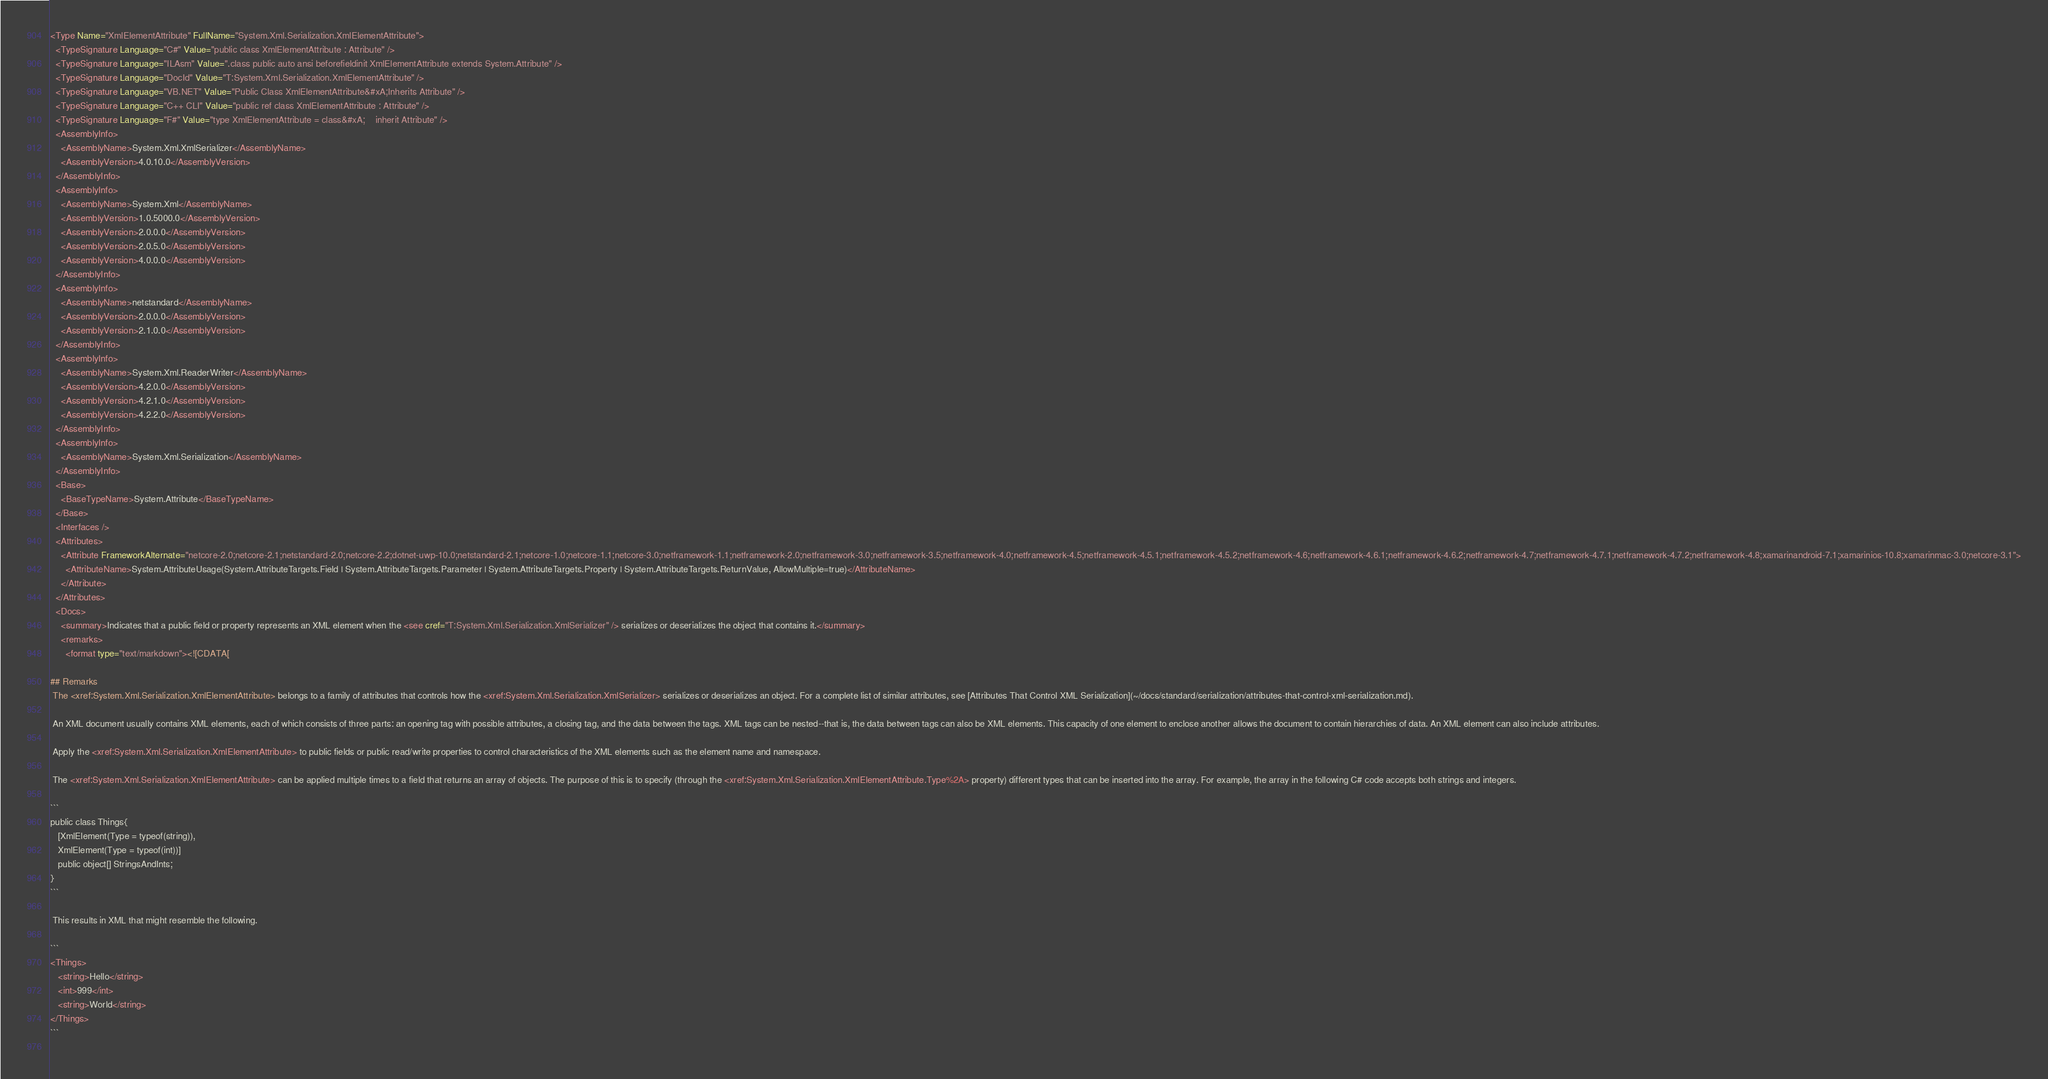Convert code to text. <code><loc_0><loc_0><loc_500><loc_500><_XML_><Type Name="XmlElementAttribute" FullName="System.Xml.Serialization.XmlElementAttribute">
  <TypeSignature Language="C#" Value="public class XmlElementAttribute : Attribute" />
  <TypeSignature Language="ILAsm" Value=".class public auto ansi beforefieldinit XmlElementAttribute extends System.Attribute" />
  <TypeSignature Language="DocId" Value="T:System.Xml.Serialization.XmlElementAttribute" />
  <TypeSignature Language="VB.NET" Value="Public Class XmlElementAttribute&#xA;Inherits Attribute" />
  <TypeSignature Language="C++ CLI" Value="public ref class XmlElementAttribute : Attribute" />
  <TypeSignature Language="F#" Value="type XmlElementAttribute = class&#xA;    inherit Attribute" />
  <AssemblyInfo>
    <AssemblyName>System.Xml.XmlSerializer</AssemblyName>
    <AssemblyVersion>4.0.10.0</AssemblyVersion>
  </AssemblyInfo>
  <AssemblyInfo>
    <AssemblyName>System.Xml</AssemblyName>
    <AssemblyVersion>1.0.5000.0</AssemblyVersion>
    <AssemblyVersion>2.0.0.0</AssemblyVersion>
    <AssemblyVersion>2.0.5.0</AssemblyVersion>
    <AssemblyVersion>4.0.0.0</AssemblyVersion>
  </AssemblyInfo>
  <AssemblyInfo>
    <AssemblyName>netstandard</AssemblyName>
    <AssemblyVersion>2.0.0.0</AssemblyVersion>
    <AssemblyVersion>2.1.0.0</AssemblyVersion>
  </AssemblyInfo>
  <AssemblyInfo>
    <AssemblyName>System.Xml.ReaderWriter</AssemblyName>
    <AssemblyVersion>4.2.0.0</AssemblyVersion>
    <AssemblyVersion>4.2.1.0</AssemblyVersion>
    <AssemblyVersion>4.2.2.0</AssemblyVersion>
  </AssemblyInfo>
  <AssemblyInfo>
    <AssemblyName>System.Xml.Serialization</AssemblyName>
  </AssemblyInfo>
  <Base>
    <BaseTypeName>System.Attribute</BaseTypeName>
  </Base>
  <Interfaces />
  <Attributes>
    <Attribute FrameworkAlternate="netcore-2.0;netcore-2.1;netstandard-2.0;netcore-2.2;dotnet-uwp-10.0;netstandard-2.1;netcore-1.0;netcore-1.1;netcore-3.0;netframework-1.1;netframework-2.0;netframework-3.0;netframework-3.5;netframework-4.0;netframework-4.5;netframework-4.5.1;netframework-4.5.2;netframework-4.6;netframework-4.6.1;netframework-4.6.2;netframework-4.7;netframework-4.7.1;netframework-4.7.2;netframework-4.8;xamarinandroid-7.1;xamarinios-10.8;xamarinmac-3.0;netcore-3.1">
      <AttributeName>System.AttributeUsage(System.AttributeTargets.Field | System.AttributeTargets.Parameter | System.AttributeTargets.Property | System.AttributeTargets.ReturnValue, AllowMultiple=true)</AttributeName>
    </Attribute>
  </Attributes>
  <Docs>
    <summary>Indicates that a public field or property represents an XML element when the <see cref="T:System.Xml.Serialization.XmlSerializer" /> serializes or deserializes the object that contains it.</summary>
    <remarks>
      <format type="text/markdown"><![CDATA[  
  
## Remarks  
 The <xref:System.Xml.Serialization.XmlElementAttribute> belongs to a family of attributes that controls how the <xref:System.Xml.Serialization.XmlSerializer> serializes or deserializes an object. For a complete list of similar attributes, see [Attributes That Control XML Serialization](~/docs/standard/serialization/attributes-that-control-xml-serialization.md).  
  
 An XML document usually contains XML elements, each of which consists of three parts: an opening tag with possible attributes, a closing tag, and the data between the tags. XML tags can be nested--that is, the data between tags can also be XML elements. This capacity of one element to enclose another allows the document to contain hierarchies of data. An XML element can also include attributes.  
  
 Apply the <xref:System.Xml.Serialization.XmlElementAttribute> to public fields or public read/write properties to control characteristics of the XML elements such as the element name and namespace.  
  
 The <xref:System.Xml.Serialization.XmlElementAttribute> can be applied multiple times to a field that returns an array of objects. The purpose of this is to specify (through the <xref:System.Xml.Serialization.XmlElementAttribute.Type%2A> property) different types that can be inserted into the array. For example, the array in the following C# code accepts both strings and integers.  
  
```  
public class Things{  
   [XmlElement(Type = typeof(string)),  
   XmlElement(Type = typeof(int))]  
   public object[] StringsAndInts;  
}  
```  
  
 This results in XML that might resemble the following.  
  
```  
<Things>  
   <string>Hello</string>  
   <int>999</int>  
   <string>World</string>  
</Things>  
```  
  </code> 